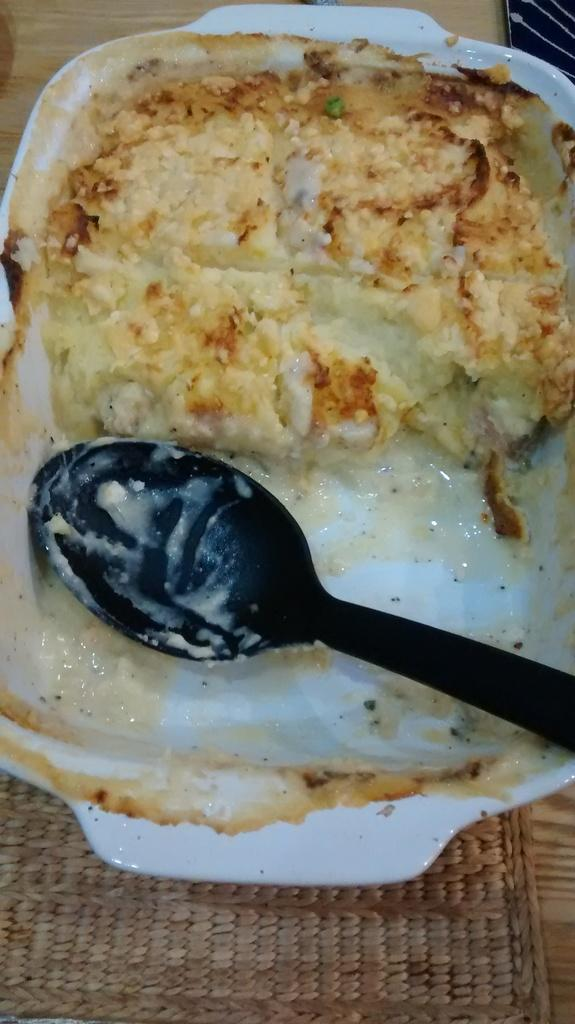What is the main subject of the image? There is a food item in the image. What utensil is present in the image? There is a spoon in the image. Where is the spoon located? The spoon is on a plate. What is the plate resting on? The plate is on a table. What type of loaf is being served on the plate in the image? There is no loaf present in the image; it features a food item and a spoon on a plate. What is the source of hope in the image? There is no reference to hope or any emotional context in the image; it simply shows a food item, a spoon, a plate, and a table. 